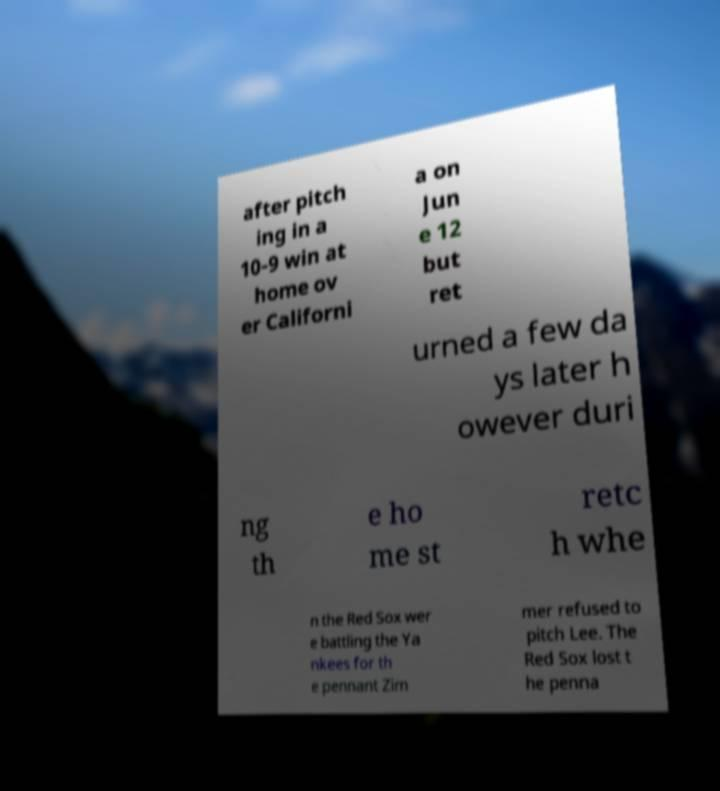Could you assist in decoding the text presented in this image and type it out clearly? after pitch ing in a 10-9 win at home ov er Californi a on Jun e 12 but ret urned a few da ys later h owever duri ng th e ho me st retc h whe n the Red Sox wer e battling the Ya nkees for th e pennant Zim mer refused to pitch Lee. The Red Sox lost t he penna 